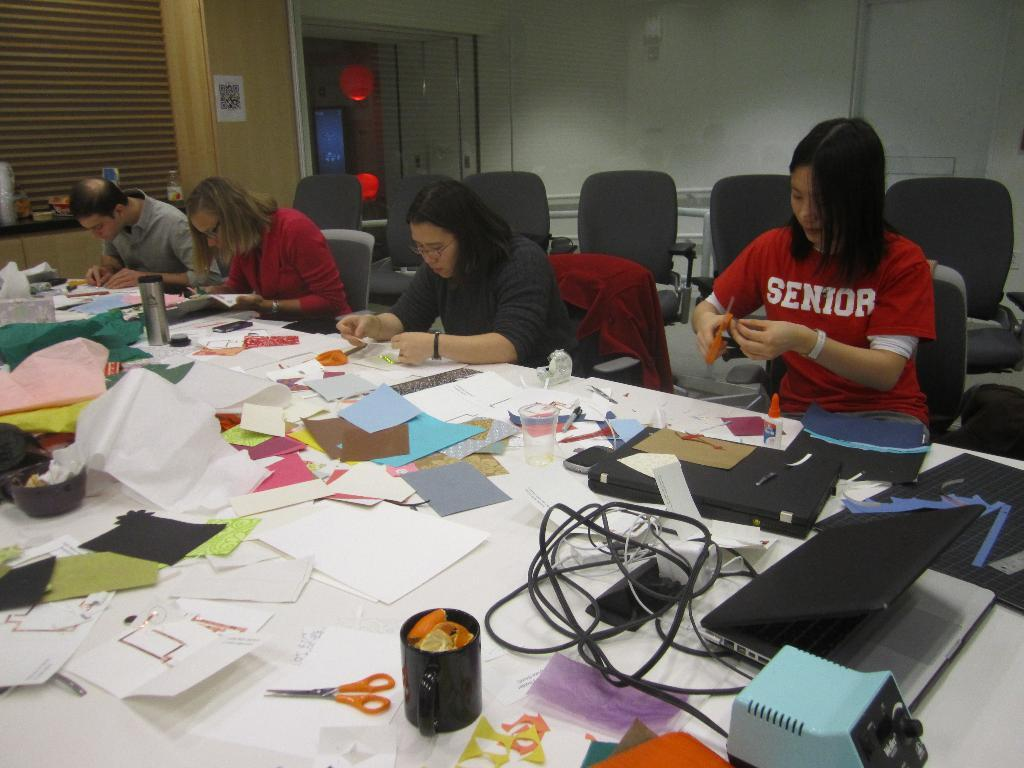Provide a one-sentence caption for the provided image. Two kids working on a project, one is wearing a senior shirt. 